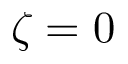<formula> <loc_0><loc_0><loc_500><loc_500>\zeta = 0</formula> 